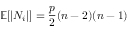<formula> <loc_0><loc_0><loc_500><loc_500>\mathbb { E } [ | N _ { i } | ] = \frac { p } { 2 } ( n - 2 ) ( n - 1 )</formula> 